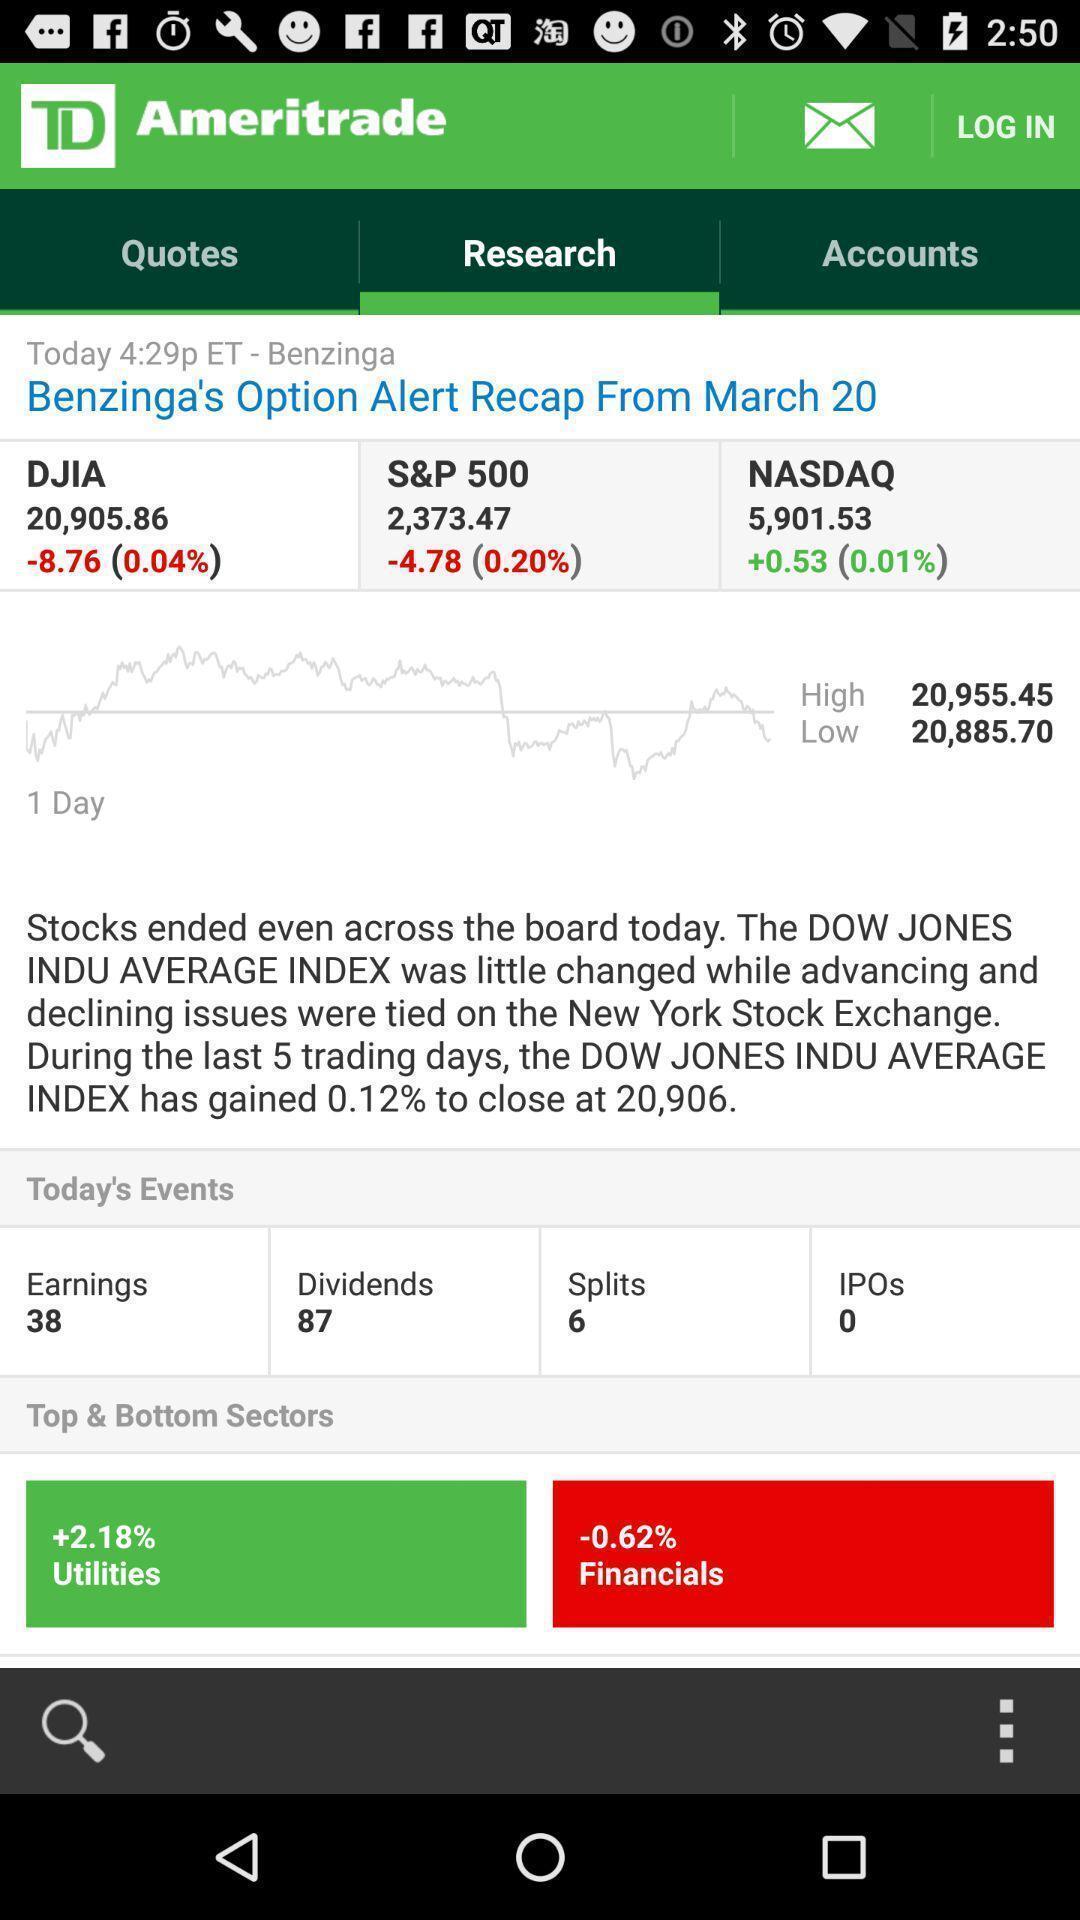Summarize the information in this screenshot. Screen displaying research page. 